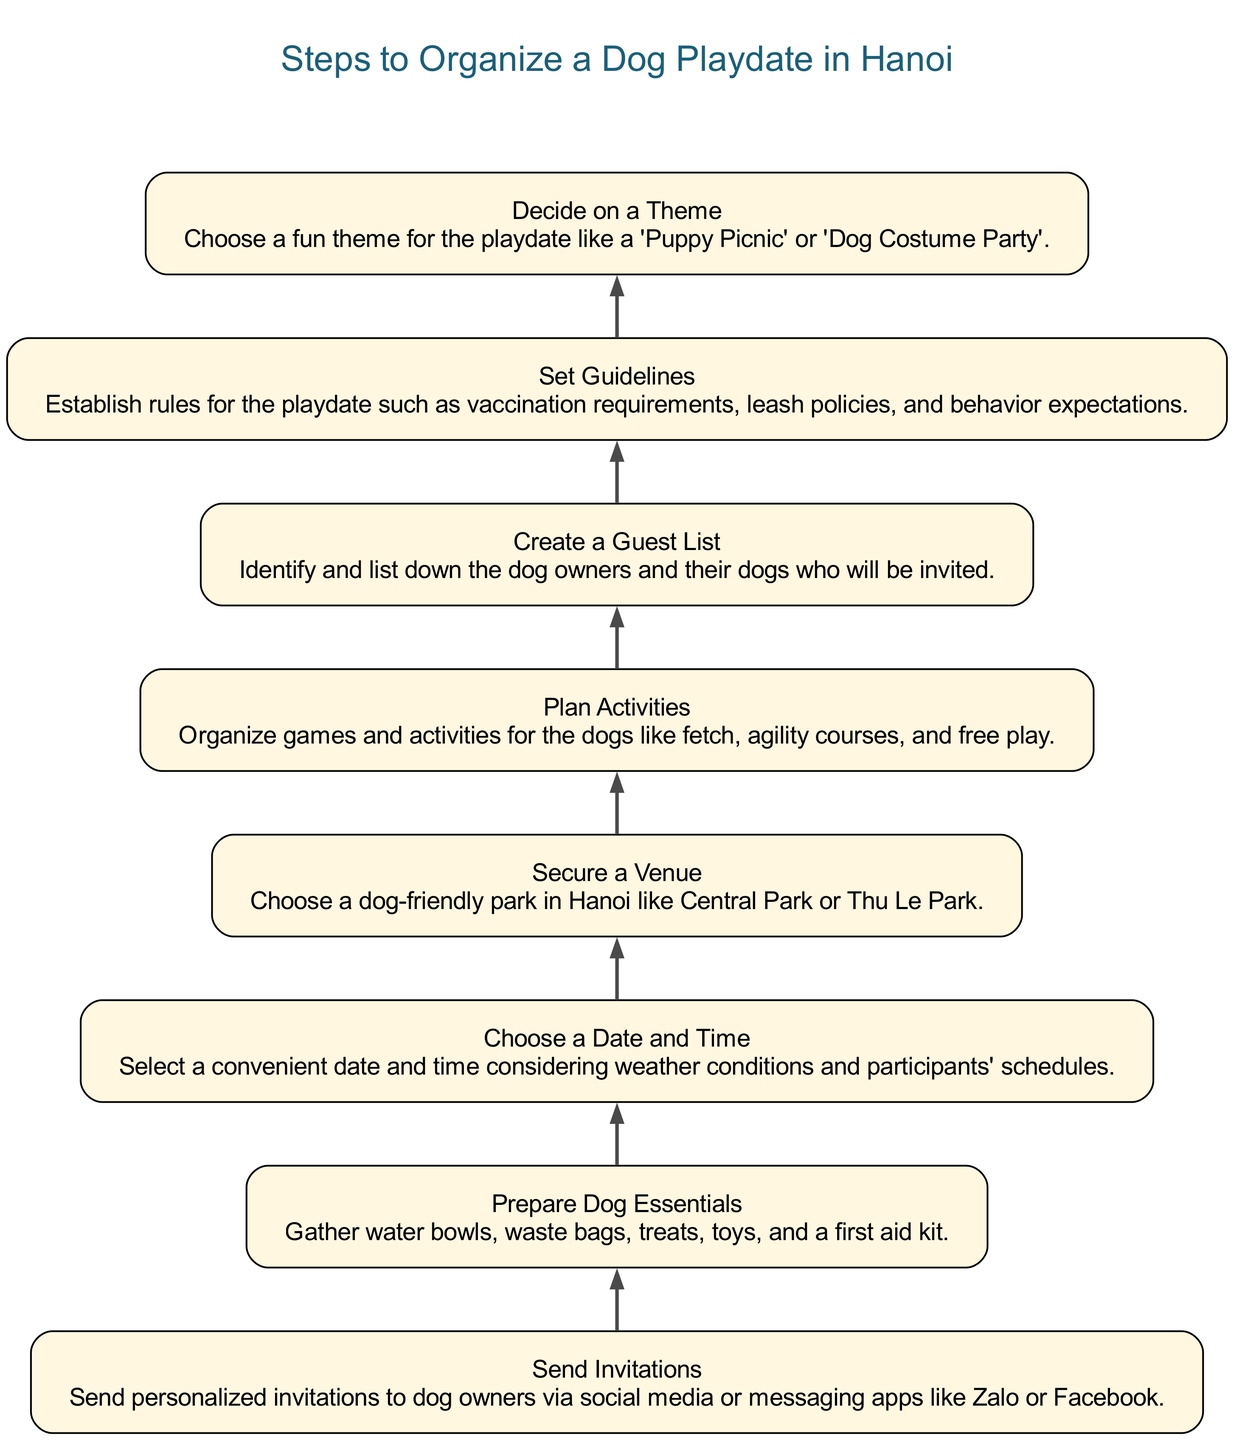What is the first step in the diagram? The first step represented at the bottom of the diagram is "Decide on a Theme." This is identified as it is the first node in the flowchart when read from bottom to top.
Answer: Decide on a Theme How many steps are there in total? The total number of distinct steps in the diagram is 8, each representing a different action in organizing a dog playdate.
Answer: 8 What is the last step in the process? The last step at the top of the diagram is "Send Invitations." This is directly above the other steps, indicating it is the final action to complete.
Answer: Send Invitations Which step follows "Secure a Venue"? After "Secure a Venue," the next step in the diagram is "Plan Activities." This is determined by looking at the flow from bottom to top within the diagram.
Answer: Plan Activities What theme is suggested for the playdate? The theme suggested for the playdate, which is mentioned in the relevant node, could be "Puppy Picnic" or "Dog Costume Party." Both are presented as examples in the step labeled "Decide on a Theme."
Answer: Puppy Picnic or Dog Costume Party How many guidelines are proposed for the playdate? The guidelines are proposed in a single step, indicated by the node titled "Set Guidelines." Even though no number is given, it represents a collective step regarding guidelines.
Answer: 1 (guidelines) What activity is planned for dogs? One of the activities planned for the dogs, as mentioned in the step "Plan Activities," is "fetch." The description indicates different games and activities, including fetch as a key highlight.
Answer: fetch What is essential to prepare before the playdate? To prepare before the playdate, it is essential to "Gather water bowls, waste bags, treats, toys, and a first aid kit," as stated in the step named "Prepare Dog Essentials."
Answer: Gather water bowls, waste bags, treats, toys, and a first aid kit 